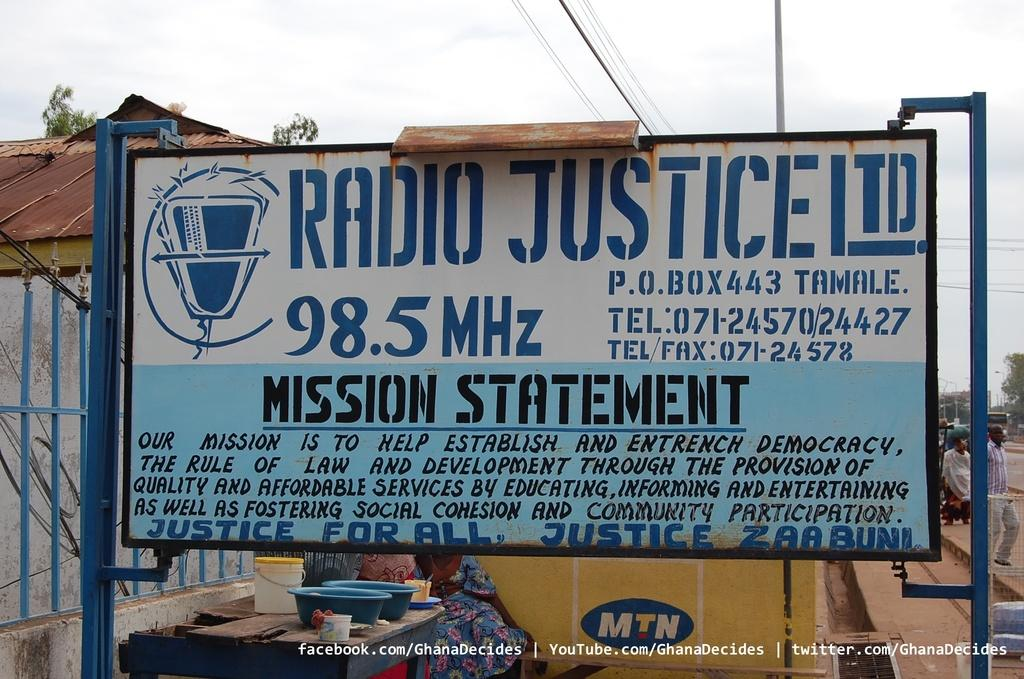What is the main object in the middle of the image? There is a board in the middle of the image, with white and blue colors. What is written on the board? There is matter written on the board. What can be seen in the background of the image? There are houses visible in the background. What are the two persons on the right side of the image doing? Two persons are walking on the right side of the image. What is visible at the top of the image? The sky is visible at the top of the image. What type of button is being pressed by the friend in the image? There is no friend or button present in the image. What disease is being discussed on the board in the image? The content of the matter written on the board is not mentioned, so it cannot be determined if a disease is being discussed. 